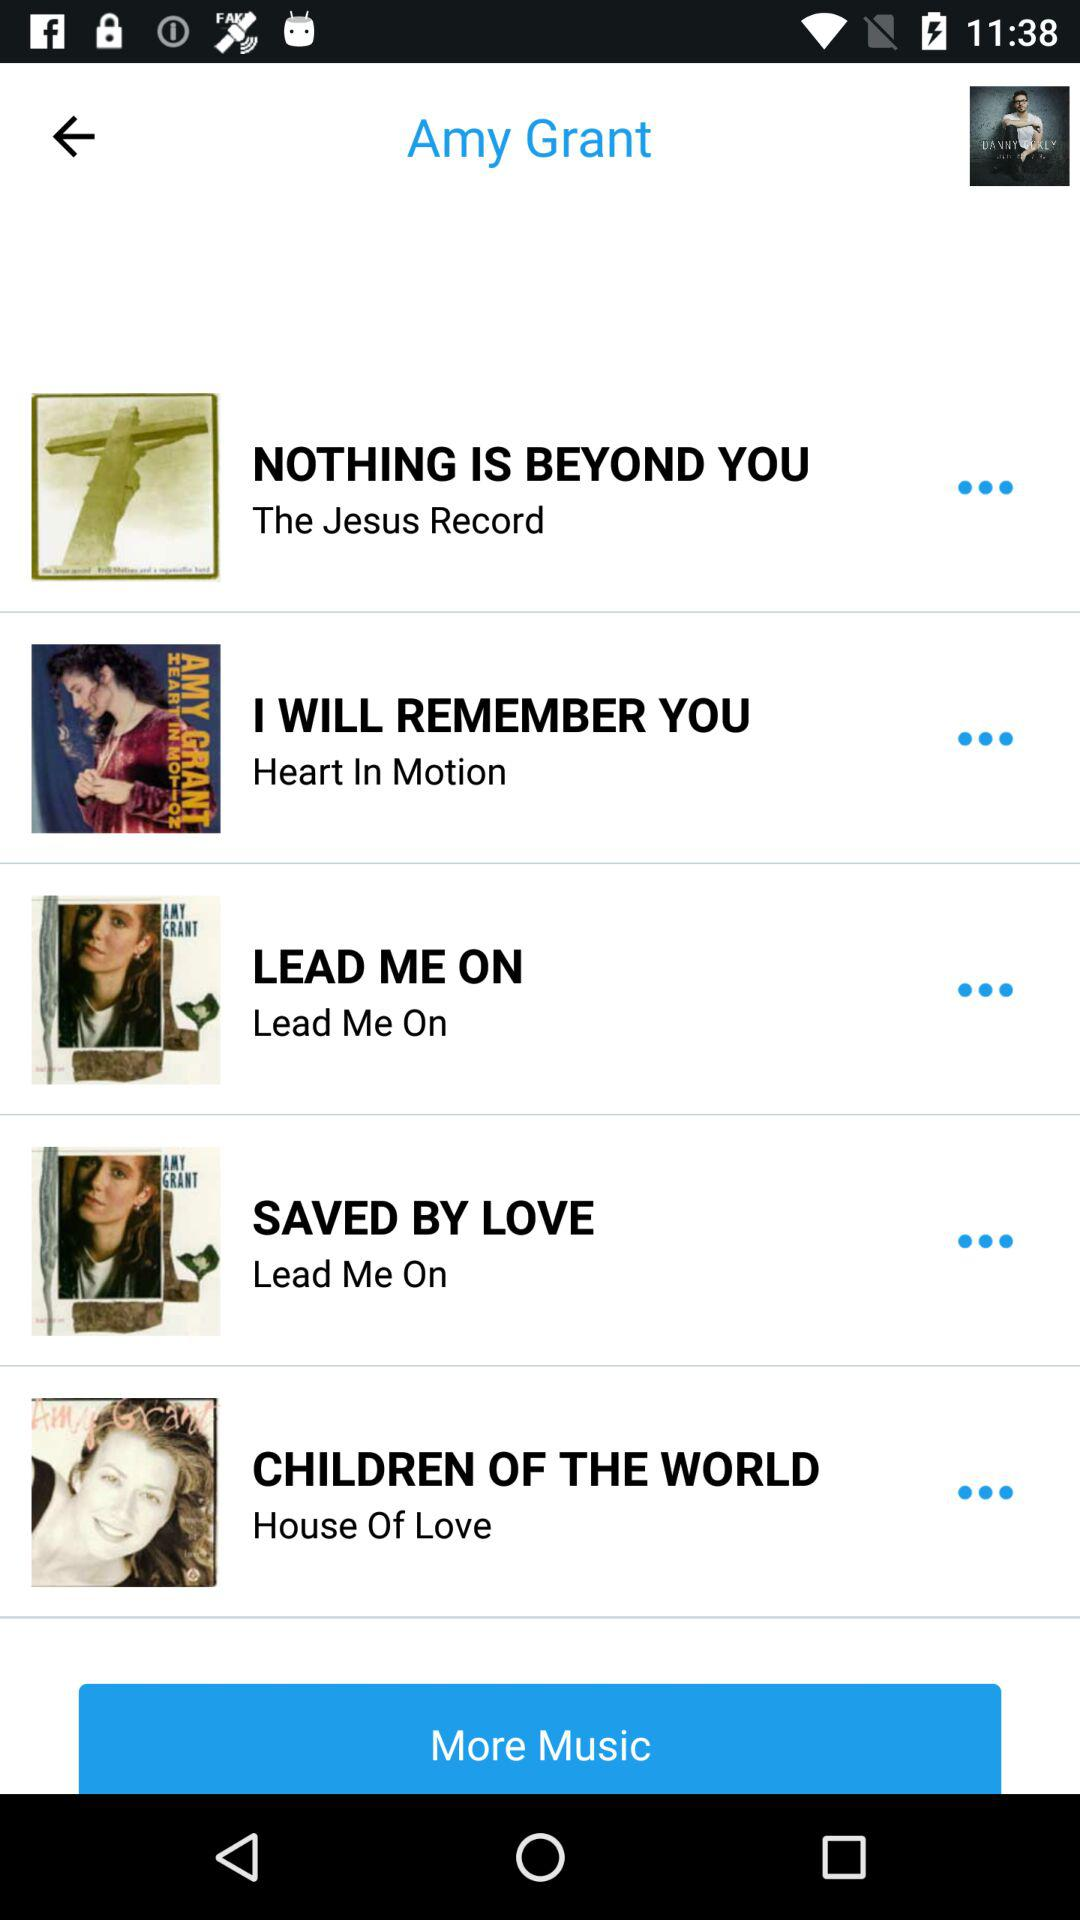"CHILDREN OF THE WORLD" belongs to which album? It belongs to "House Of Love" album. 